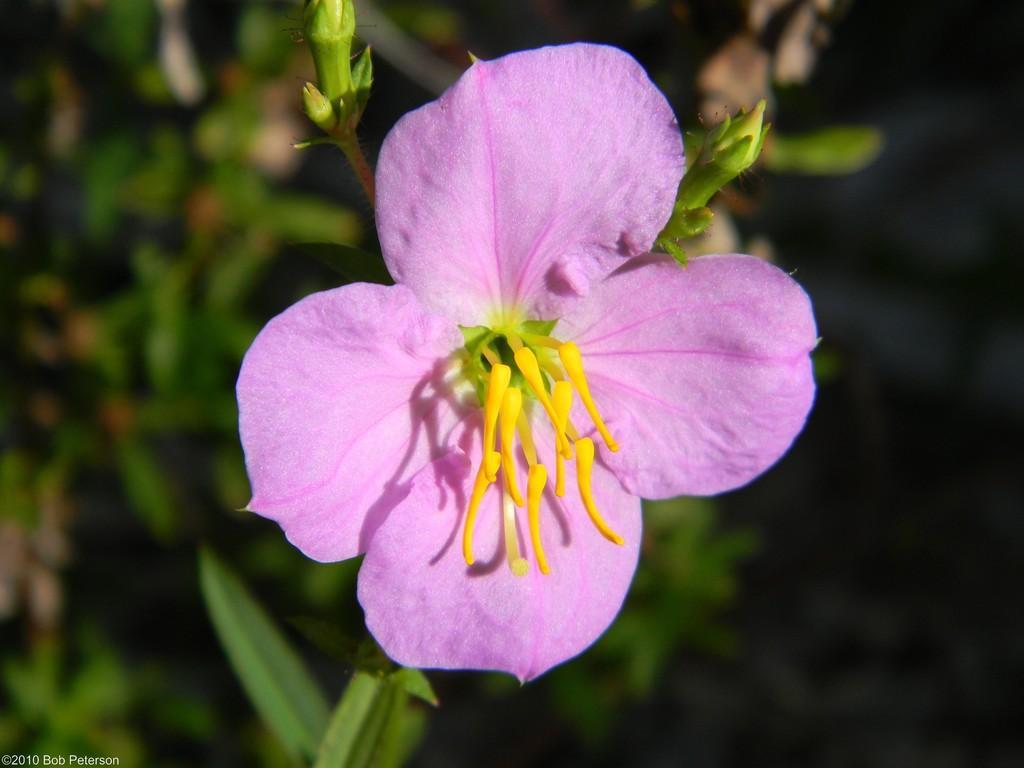Describe this image in one or two sentences. In this image we can see a flower and buds on the stem of a plant. In the background, we can see some plants. At the bottom we can see some text. 